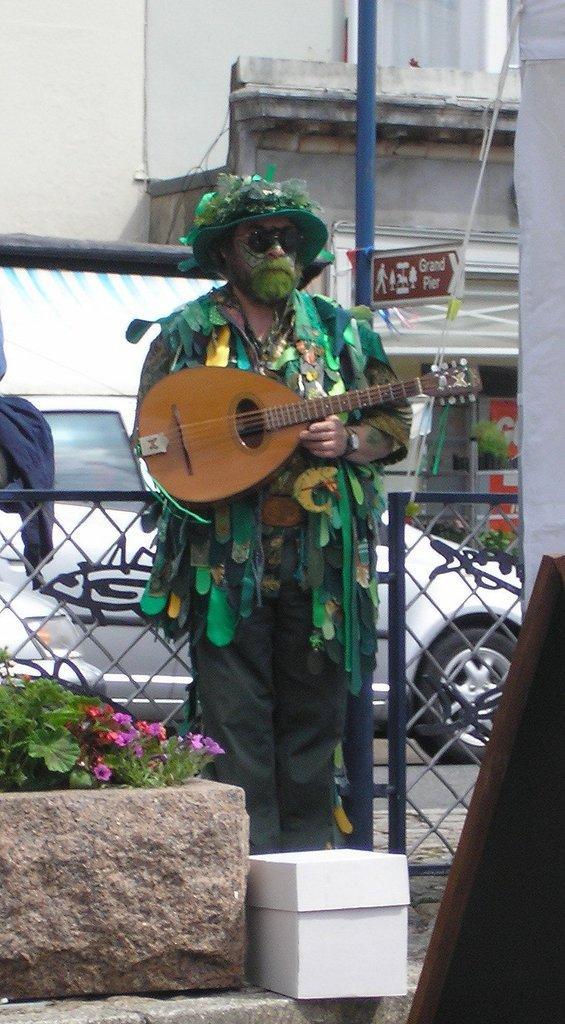How would you summarize this image in a sentence or two? In this picture we can see man wore cap, goggle holding guitar in his hand and in front of him we can see flowers, box and at back of him we can see fence, car, building, pole, sign board. 